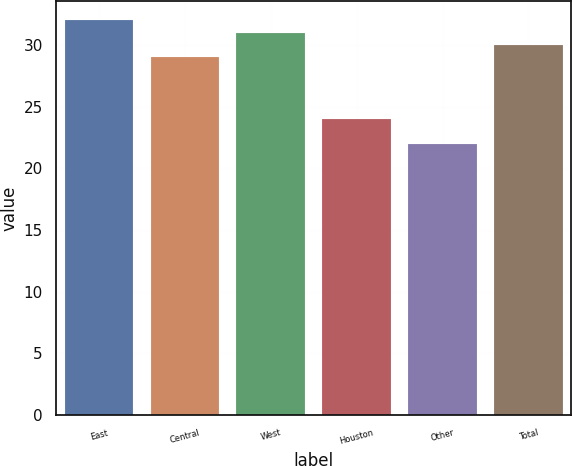<chart> <loc_0><loc_0><loc_500><loc_500><bar_chart><fcel>East<fcel>Central<fcel>West<fcel>Houston<fcel>Other<fcel>Total<nl><fcel>32<fcel>29<fcel>31<fcel>24<fcel>22<fcel>30<nl></chart> 